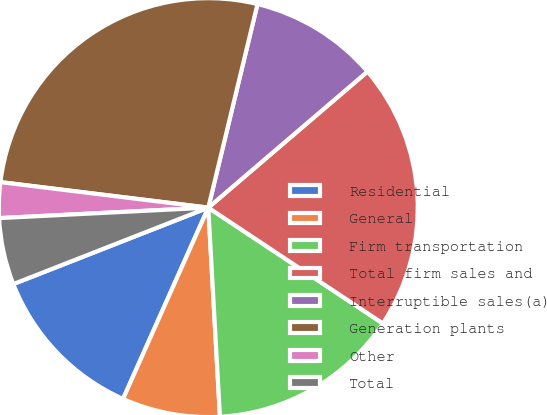Convert chart to OTSL. <chart><loc_0><loc_0><loc_500><loc_500><pie_chart><fcel>Residential<fcel>General<fcel>Firm transportation<fcel>Total firm sales and<fcel>Interruptible sales(a)<fcel>Generation plants<fcel>Other<fcel>Total<nl><fcel>12.38%<fcel>7.56%<fcel>14.79%<fcel>20.58%<fcel>9.97%<fcel>26.83%<fcel>2.74%<fcel>5.15%<nl></chart> 